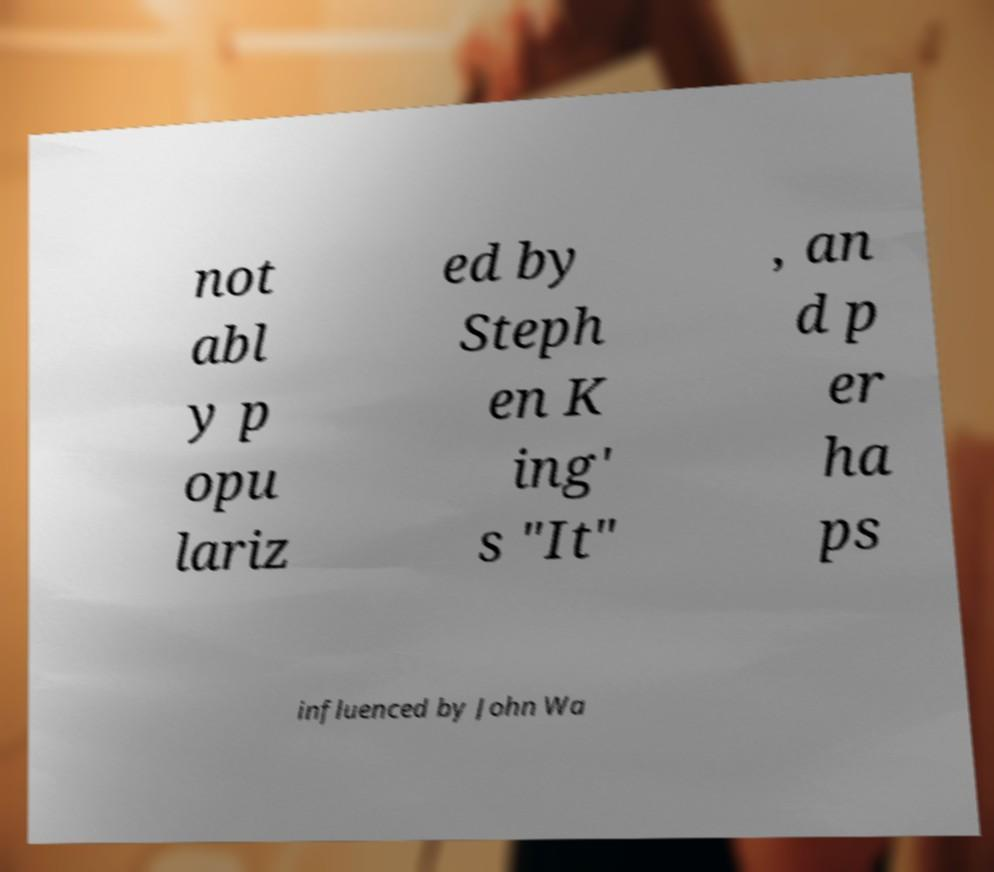Could you extract and type out the text from this image? not abl y p opu lariz ed by Steph en K ing' s "It" , an d p er ha ps influenced by John Wa 